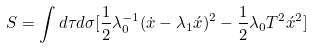Convert formula to latex. <formula><loc_0><loc_0><loc_500><loc_500>S = \int d \tau d \sigma [ \frac { 1 } { 2 } \lambda _ { 0 } ^ { - 1 } ( \dot { x } - \lambda _ { 1 } \acute { x } ) ^ { 2 } - \frac { 1 } { 2 } \lambda _ { 0 } T ^ { 2 } \acute { x } ^ { 2 } ]</formula> 